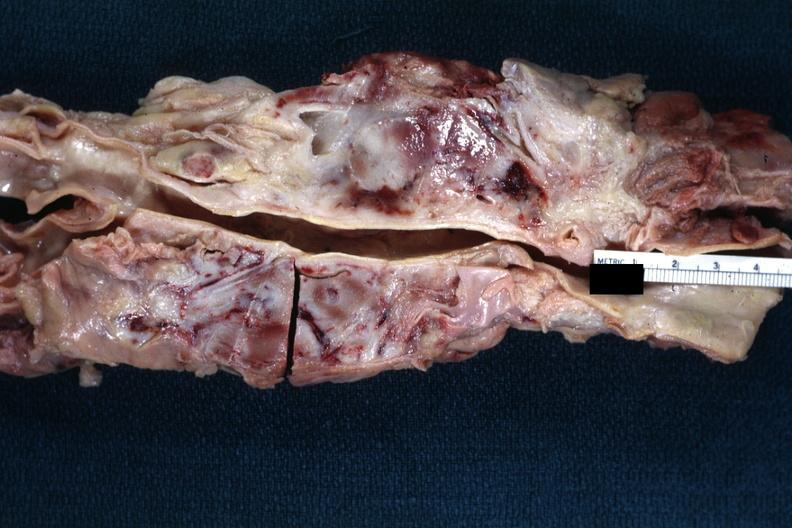s malignant lymphoma present?
Answer the question using a single word or phrase. Yes 